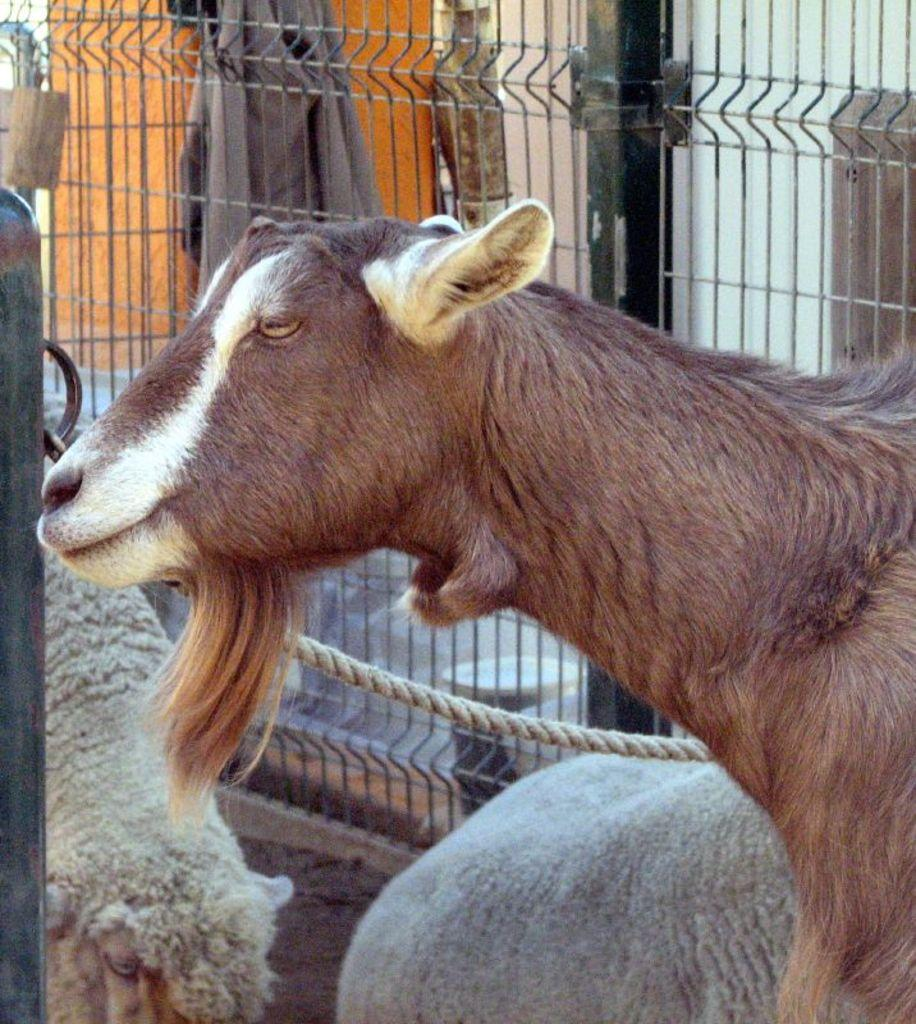What type of animals are present in the image? There is a goat and a sheep in the image. What is the material of the fence in the background? The fence in the background is made of metal. What additional object can be seen in the image? There is a cloth in the image. What type of payment is being made to the goat in the image? There is no payment being made in the image, as it features a goat and a sheep with a metal fence and a cloth. 